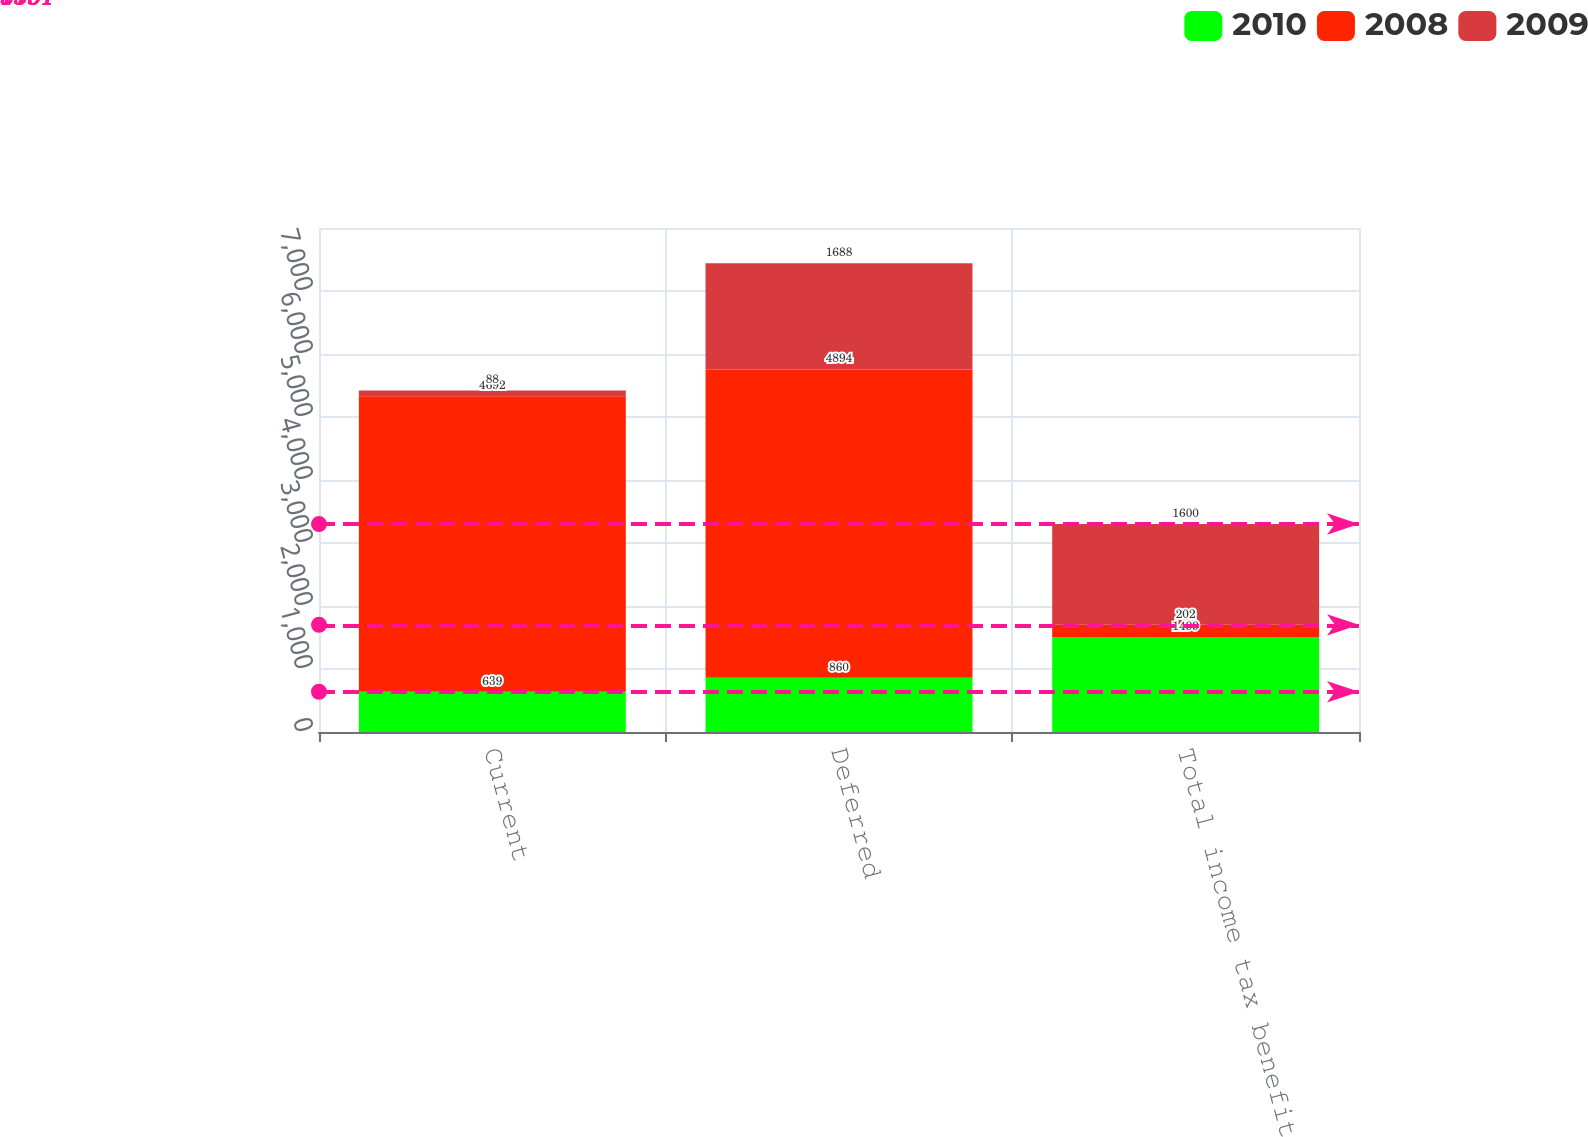Convert chart to OTSL. <chart><loc_0><loc_0><loc_500><loc_500><stacked_bar_chart><ecel><fcel>Current<fcel>Deferred<fcel>Total income tax benefit<nl><fcel>2010<fcel>639<fcel>860<fcel>1499<nl><fcel>2008<fcel>4692<fcel>4894<fcel>202<nl><fcel>2009<fcel>88<fcel>1688<fcel>1600<nl></chart> 